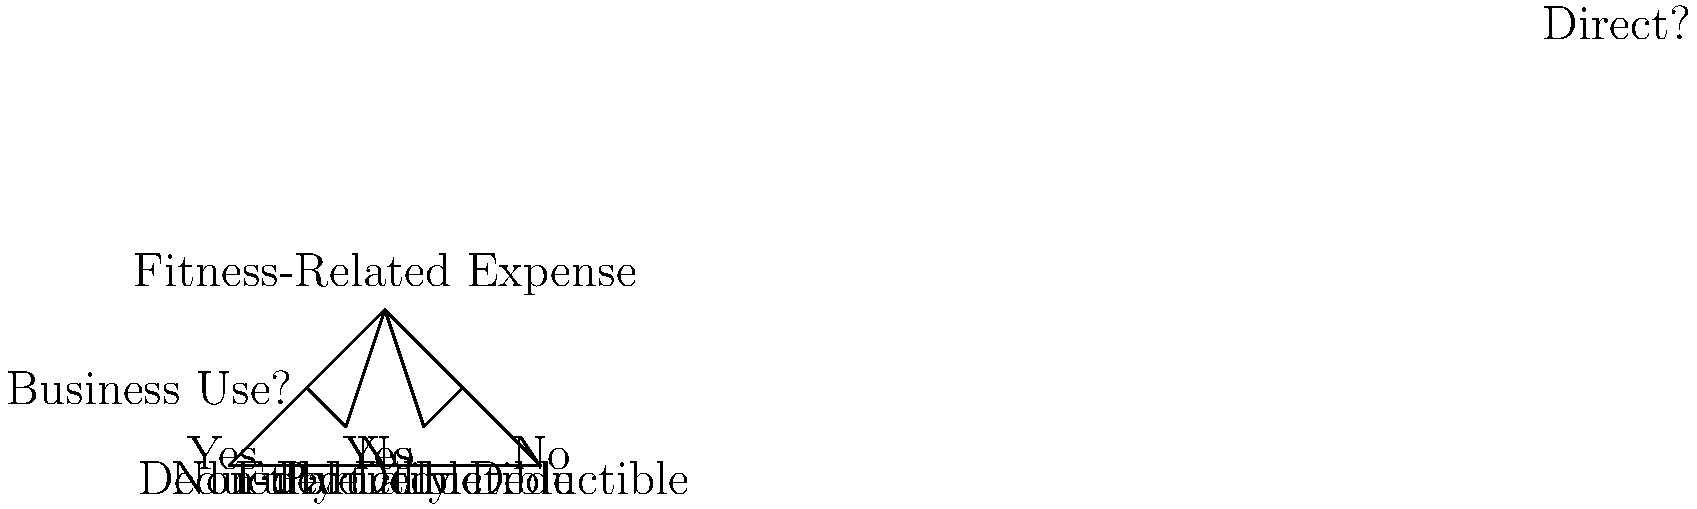As a tax accountant specializing in the fitness industry, you're advising a client on classifying their fitness-related expenses. Using the decision tree diagram provided, determine the tax treatment for a new treadmill purchased by a personal trainer who uses it 60% for client demonstrations and 40% for personal use. To determine the tax treatment for the treadmill, we'll follow the decision tree step-by-step:

1. Start at the top with "Fitness-Related Expense".

2. Move to "Business Use?":
   - The treadmill is used 60% for client demonstrations, so there is business use.
   - We follow the "Yes" branch.

3. Move to "Direct?":
   - The treadmill is not used 100% for business, as it has 40% personal use.
   - We follow the "No" branch.

4. We arrive at "Partially Deductible".

The treadmill is partially deductible because:
- It has a legitimate business use (client demonstrations).
- It's not used exclusively for business purposes.

In this case, the personal trainer can deduct 60% of the treadmill's cost as a business expense, corresponding to the percentage of business use. The remaining 40% is considered personal use and is not deductible.

To calculate the deductible amount:
Let $C$ be the cost of the treadmill.
Deductible amount $= 60\% \times C = 0.6C$

The personal trainer should keep detailed records of the treadmill's use to support this allocation in case of an audit.
Answer: Partially deductible (60% of cost) 